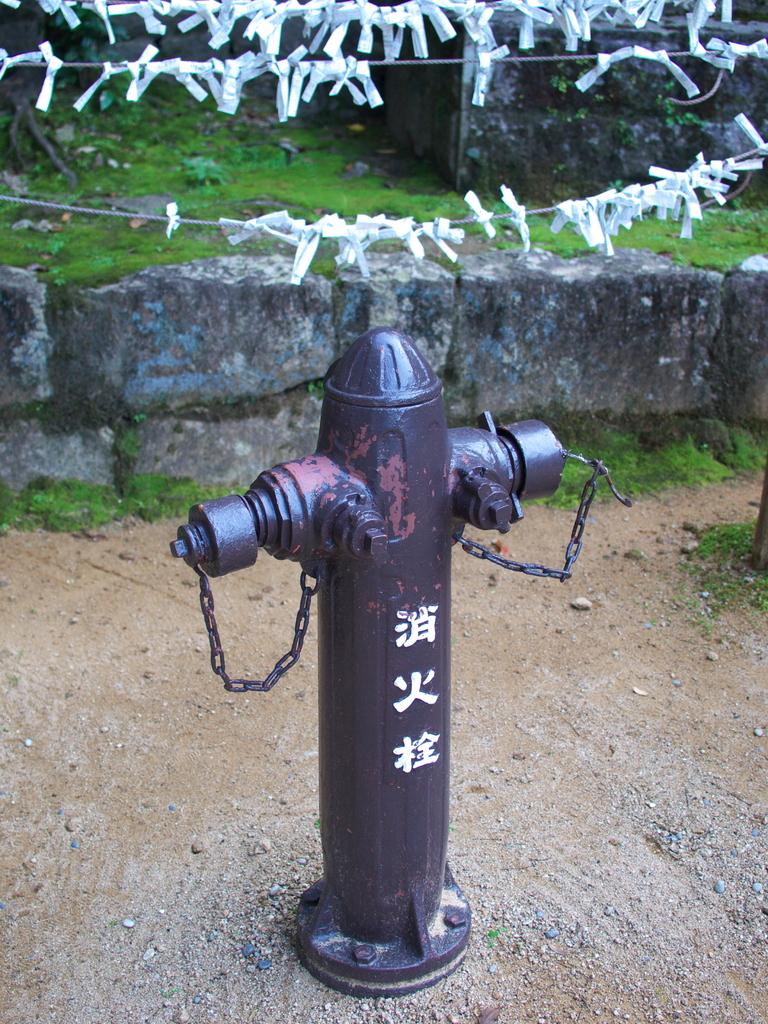What is on the ground in the image? There is a pole with chains on the ground. What is hanging above the pole? Decorative papers are attached to threads above the pole. What can be seen in the background of the image? There is a wall in the background. What type of surface is the pole and chains placed on? Grass is present on the ground. How many women are holding wine glasses in the image? There are no women or wine glasses present in the image. What type of weather is suggested by the presence of grass in the image? The presence of grass does not necessarily indicate a specific season or weather; it simply suggests that the ground is covered with grass. 